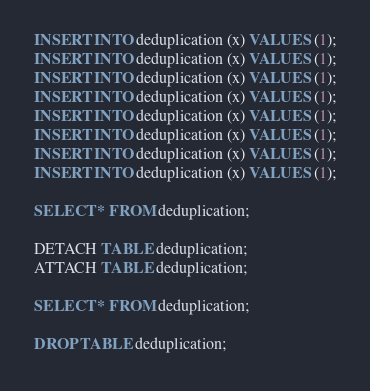Convert code to text. <code><loc_0><loc_0><loc_500><loc_500><_SQL_>INSERT INTO deduplication (x) VALUES (1);
INSERT INTO deduplication (x) VALUES (1);
INSERT INTO deduplication (x) VALUES (1);
INSERT INTO deduplication (x) VALUES (1);
INSERT INTO deduplication (x) VALUES (1);
INSERT INTO deduplication (x) VALUES (1);
INSERT INTO deduplication (x) VALUES (1);
INSERT INTO deduplication (x) VALUES (1);

SELECT * FROM deduplication;

DETACH TABLE deduplication;
ATTACH TABLE deduplication;

SELECT * FROM deduplication;

DROP TABLE deduplication;
</code> 